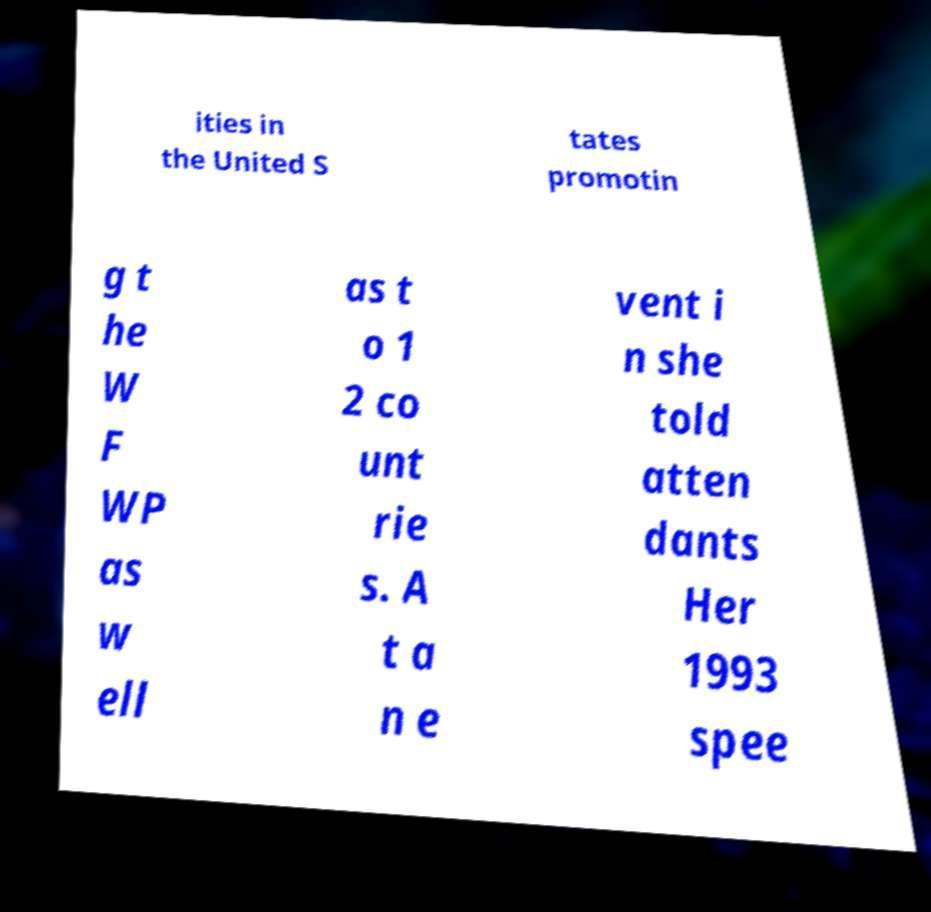Could you extract and type out the text from this image? ities in the United S tates promotin g t he W F WP as w ell as t o 1 2 co unt rie s. A t a n e vent i n she told atten dants Her 1993 spee 